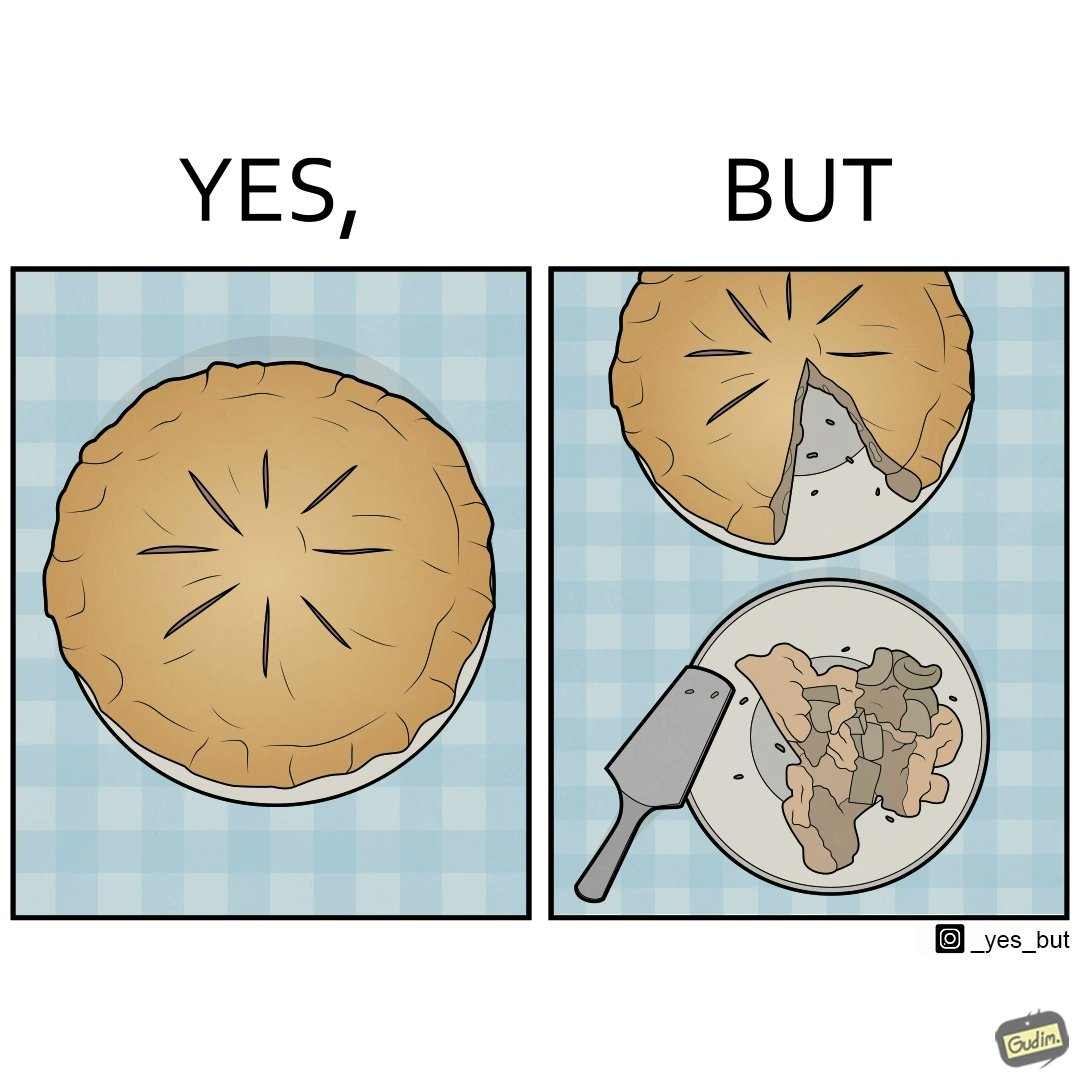Describe the satirical element in this image. The image is funny because why people like to get whole pies, they only end up eating a small portion of it wasting the rest of the pie. 